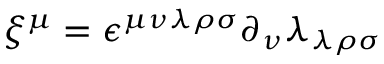<formula> <loc_0><loc_0><loc_500><loc_500>\xi ^ { \mu } = \epsilon ^ { \mu \nu \lambda \rho \sigma } \partial _ { \nu } \lambda _ { \lambda \rho \sigma }</formula> 